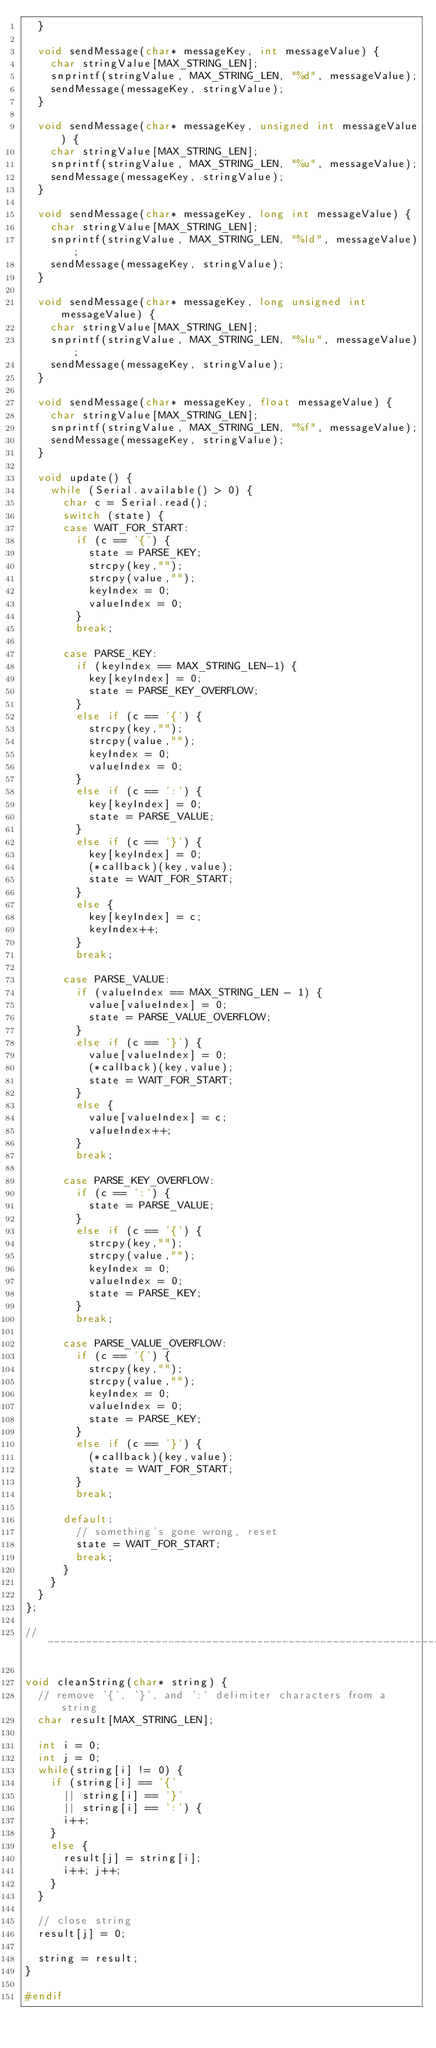Convert code to text. <code><loc_0><loc_0><loc_500><loc_500><_C++_>  }

  void sendMessage(char* messageKey, int messageValue) {
    char stringValue[MAX_STRING_LEN];
    snprintf(stringValue, MAX_STRING_LEN, "%d", messageValue);
    sendMessage(messageKey, stringValue);
  }

  void sendMessage(char* messageKey, unsigned int messageValue) {
    char stringValue[MAX_STRING_LEN];
    snprintf(stringValue, MAX_STRING_LEN, "%u", messageValue);
    sendMessage(messageKey, stringValue);
  }

  void sendMessage(char* messageKey, long int messageValue) {
    char stringValue[MAX_STRING_LEN];
    snprintf(stringValue, MAX_STRING_LEN, "%ld", messageValue);
    sendMessage(messageKey, stringValue);
  }

  void sendMessage(char* messageKey, long unsigned int messageValue) {
    char stringValue[MAX_STRING_LEN];
    snprintf(stringValue, MAX_STRING_LEN, "%lu", messageValue);
    sendMessage(messageKey, stringValue);
  }

  void sendMessage(char* messageKey, float messageValue) {
    char stringValue[MAX_STRING_LEN];
    snprintf(stringValue, MAX_STRING_LEN, "%f", messageValue);
    sendMessage(messageKey, stringValue);
  }

  void update() {
    while (Serial.available() > 0) {
      char c = Serial.read();
      switch (state) {
      case WAIT_FOR_START:
        if (c == '{') {
          state = PARSE_KEY;
          strcpy(key,"");
          strcpy(value,"");
          keyIndex = 0;
          valueIndex = 0;
        }
        break;

      case PARSE_KEY:
        if (keyIndex == MAX_STRING_LEN-1) {
          key[keyIndex] = 0;
          state = PARSE_KEY_OVERFLOW;
        }
        else if (c == '{') {
          strcpy(key,"");
          strcpy(value,"");
          keyIndex = 0;
          valueIndex = 0;
        }
        else if (c == ':') {
          key[keyIndex] = 0;
          state = PARSE_VALUE;
        }
        else if (c == '}') {
          key[keyIndex] = 0;
          (*callback)(key,value);
          state = WAIT_FOR_START;
        }
        else {
          key[keyIndex] = c;
          keyIndex++;
        }
        break;

      case PARSE_VALUE:
        if (valueIndex == MAX_STRING_LEN - 1) {
          value[valueIndex] = 0;
          state = PARSE_VALUE_OVERFLOW;
        }
        else if (c == '}') {
          value[valueIndex] = 0;
          (*callback)(key,value);
          state = WAIT_FOR_START;
        }
        else {
          value[valueIndex] = c;
          valueIndex++;
        }
        break;

      case PARSE_KEY_OVERFLOW:
        if (c == ':') {
          state = PARSE_VALUE;
        }
        else if (c == '{') {
          strcpy(key,"");
          strcpy(value,"");
          keyIndex = 0;
          valueIndex = 0;
          state = PARSE_KEY;
        }
        break;

      case PARSE_VALUE_OVERFLOW:
        if (c == '{') {
          strcpy(key,"");
          strcpy(value,"");
          keyIndex = 0;
          valueIndex = 0;
          state = PARSE_KEY;
        }
        else if (c == '}') {
          (*callback)(key,value);
          state = WAIT_FOR_START;
        }
        break;

      default:
        // something's gone wrong, reset
        state = WAIT_FOR_START;
        break;
      }
    }
  }
};

// ~~~~~~~~~~~~~~~~~~~~~~~~~~~~~~~~~~~~~~~~~~~~~~~~~~~~~~~~~~~~~~~~

void cleanString(char* string) {
  // remove '{', '}', and ':' delimiter characters from a string
  char result[MAX_STRING_LEN];

  int i = 0;
  int j = 0;
  while(string[i] != 0) {
    if (string[i] == '{'
      || string[i] == '}'
      || string[i] == ':') {
      i++;
    }
    else {
      result[j] = string[i];
      i++; j++;
    }
  }

  // close string
  result[j] = 0;

  string = result;
}

#endif
</code> 